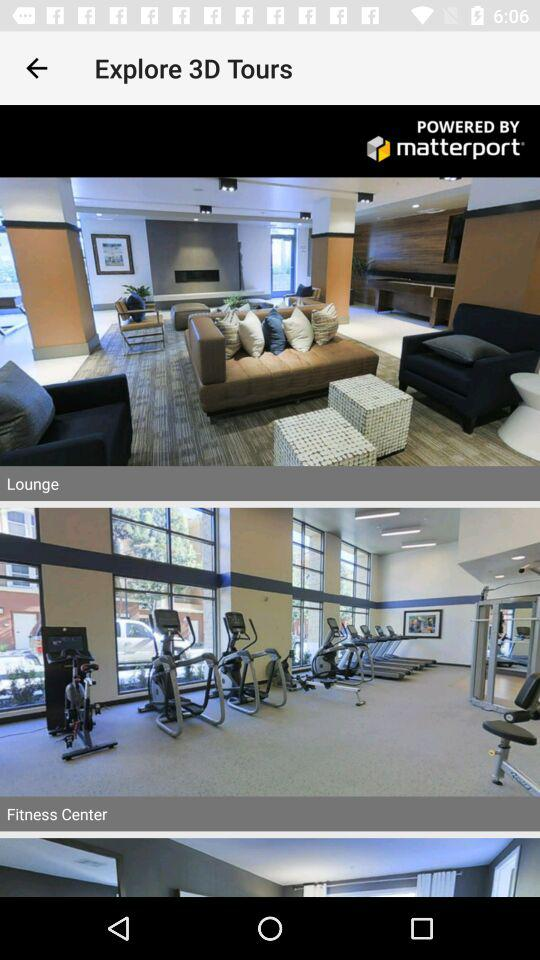What is the app name?
When the provided information is insufficient, respond with <no answer>. <no answer> 